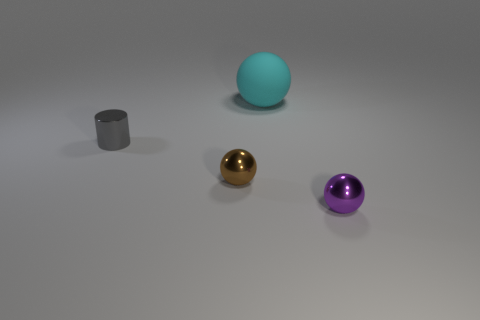Subtract all tiny shiny spheres. How many spheres are left? 1 Subtract all brown balls. How many balls are left? 2 Add 2 tiny gray cylinders. How many objects exist? 6 Subtract 3 balls. How many balls are left? 0 Subtract all red blocks. How many blue spheres are left? 0 Add 3 purple spheres. How many purple spheres are left? 4 Add 3 small things. How many small things exist? 6 Subtract 0 yellow cylinders. How many objects are left? 4 Subtract all balls. How many objects are left? 1 Subtract all blue spheres. Subtract all blue cubes. How many spheres are left? 3 